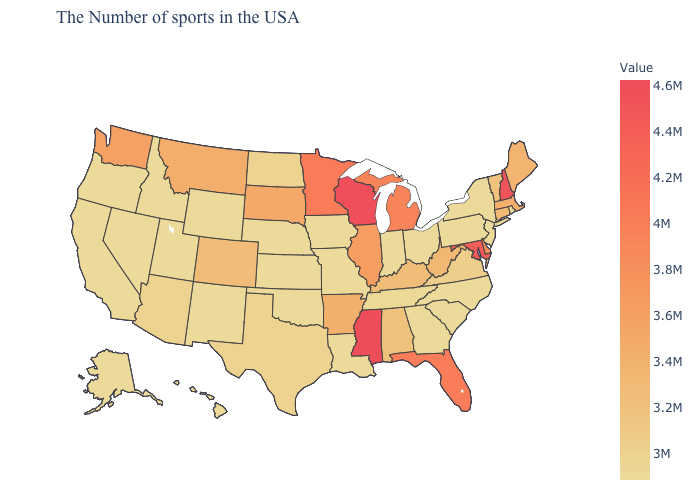Does the map have missing data?
Short answer required. No. Is the legend a continuous bar?
Quick response, please. Yes. Among the states that border Oregon , which have the lowest value?
Give a very brief answer. Idaho, Nevada, California. Does Mississippi have the highest value in the USA?
Short answer required. Yes. Is the legend a continuous bar?
Answer briefly. Yes. Does the map have missing data?
Concise answer only. No. 